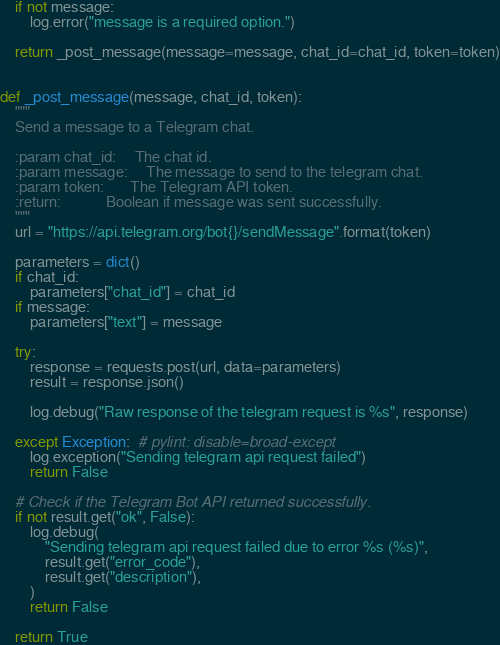<code> <loc_0><loc_0><loc_500><loc_500><_Python_>
    if not message:
        log.error("message is a required option.")

    return _post_message(message=message, chat_id=chat_id, token=token)


def _post_message(message, chat_id, token):
    """
    Send a message to a Telegram chat.

    :param chat_id:     The chat id.
    :param message:     The message to send to the telegram chat.
    :param token:       The Telegram API token.
    :return:            Boolean if message was sent successfully.
    """
    url = "https://api.telegram.org/bot{}/sendMessage".format(token)

    parameters = dict()
    if chat_id:
        parameters["chat_id"] = chat_id
    if message:
        parameters["text"] = message

    try:
        response = requests.post(url, data=parameters)
        result = response.json()

        log.debug("Raw response of the telegram request is %s", response)

    except Exception:  # pylint: disable=broad-except
        log.exception("Sending telegram api request failed")
        return False

    # Check if the Telegram Bot API returned successfully.
    if not result.get("ok", False):
        log.debug(
            "Sending telegram api request failed due to error %s (%s)",
            result.get("error_code"),
            result.get("description"),
        )
        return False

    return True
</code> 